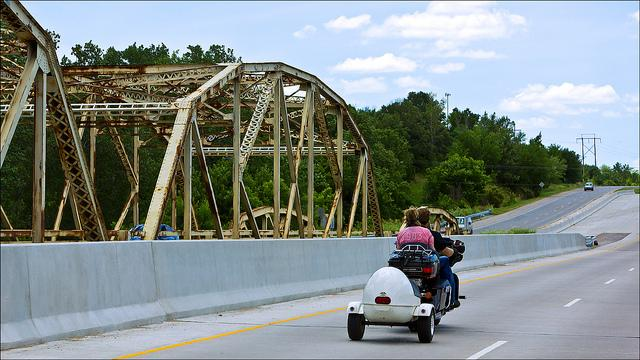What is next to the vehicle?

Choices:
A) walrus
B) antelope
C) airplane
D) bridge bridge 